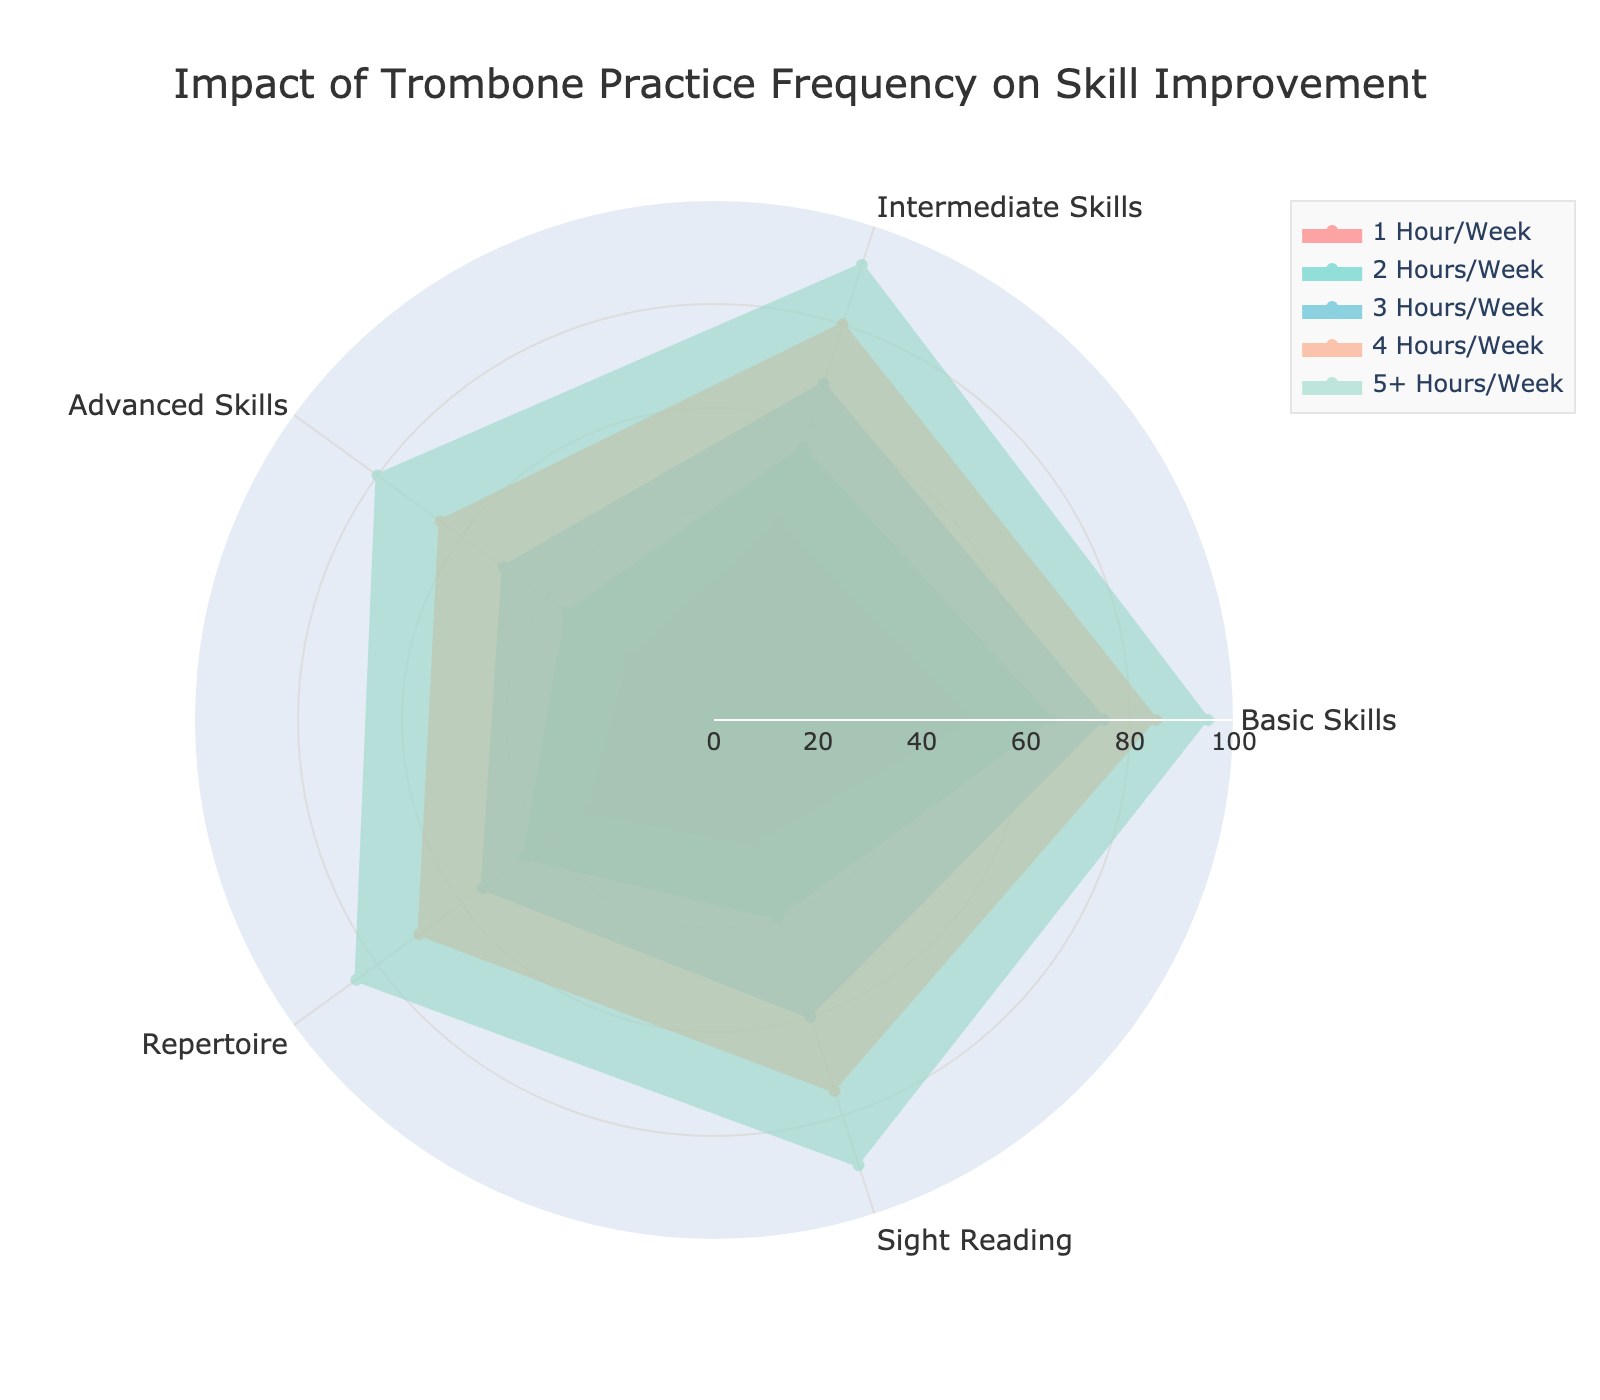What is the title of the figure? The title is usually at the top of the figure and clearly describes the main focus of the chart.
Answer: Impact of Trombone Practice Frequency on Skill Improvement Which practice frequency shows the highest improvement in Basic Skills? By looking at the radar chart, find the practice frequency line that reaches the highest point in the Basic Skills category.
Answer: 5+ Hours/Week What is the difference in Sight Reading improvement between practicing 1 Hour/Week and 5+ Hours/Week? Locate the values for Sight Reading at 1 Hour/Week and 5+ Hours/Week. Subtract the lower value from the higher value (90 - 25).
Answer: 65 How many practice frequencies are shown in the radar chart? Count the number of different lines or categories in the radar chart, each representing a practice frequency.
Answer: 5 Which skill shows the least improvement when practicing 2 Hours/Week? Find the lowest point on the radar chart for the 2 Hours/Week line among all skill categories.
Answer: Advanced Skills What is the average improvement in Repertoire for all practice frequencies? Add up the Repertoire values for all practice frequencies (30 + 45 + 55 + 70 + 85) and divide by the number of frequencies (5).
Answer: 57 Compare the improvement in Intermediate Skills between practicing 3 Hours/Week and 4 Hours/Week. Locate and compare the values for Intermediate Skills at 3 Hours/Week and 4 Hours/Week (80 - 68).
Answer: 12 Which practice frequency shows the highest average improvement across all skills? Calculate the average improvement for each practice frequency and compare them. Sum the values for each frequency and divide by the number of skills, then find the highest.
Answer: 5+ Hours/Week How does the improvement in Advanced Skills for 4 Hours/Week compare to Basic Skills for the same practice frequency? Compare the two values directly on the radar chart for 4 Hours/Week in Advanced Skills and Basic Skills.
Answer: Advanced Skills < Basic Skills What is the range of improvement for Sight Reading across all practice frequencies? Identify the highest and lowest values for Sight Reading, then subtract the lowest from the highest (90 - 25).
Answer: 65 